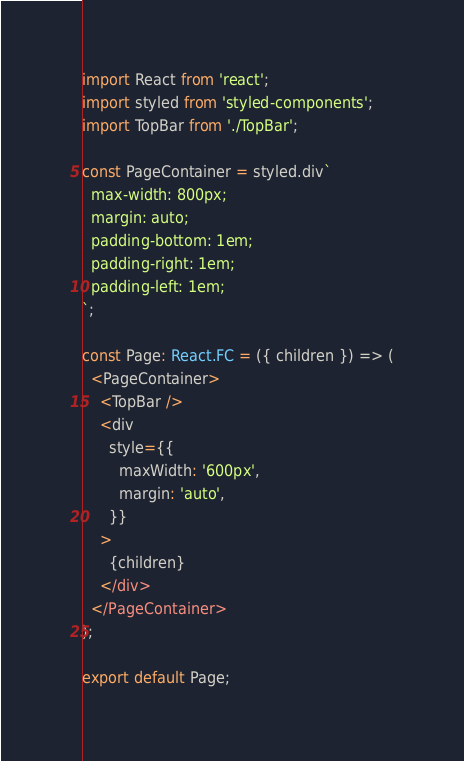<code> <loc_0><loc_0><loc_500><loc_500><_TypeScript_>import React from 'react';
import styled from 'styled-components';
import TopBar from './TopBar';

const PageContainer = styled.div`
  max-width: 800px;
  margin: auto;
  padding-bottom: 1em;
  padding-right: 1em;
  padding-left: 1em;
`;

const Page: React.FC = ({ children }) => (
  <PageContainer>
    <TopBar />
    <div
      style={{
        maxWidth: '600px',
        margin: 'auto',
      }}
    >
      {children}
    </div>
  </PageContainer>
);

export default Page;
</code> 